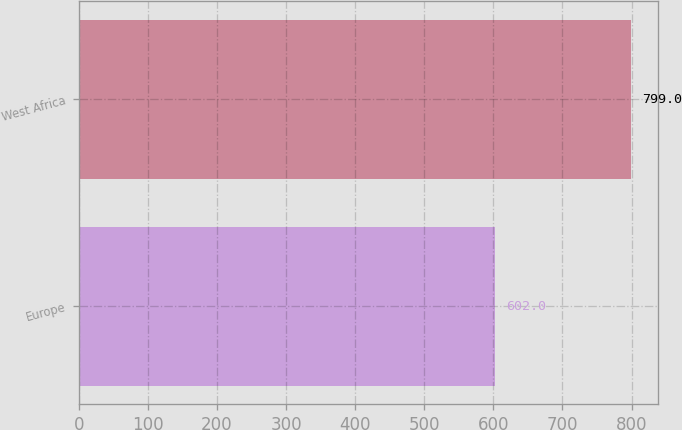<chart> <loc_0><loc_0><loc_500><loc_500><bar_chart><fcel>Europe<fcel>West Africa<nl><fcel>602<fcel>799<nl></chart> 